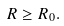Convert formula to latex. <formula><loc_0><loc_0><loc_500><loc_500>R \geq R _ { 0 } .</formula> 